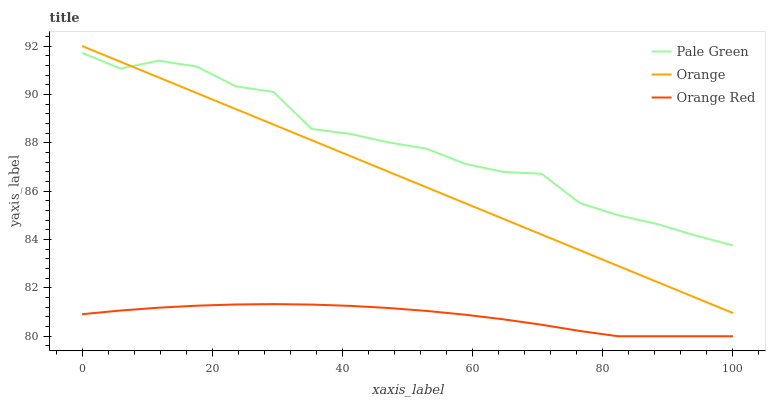Does Orange Red have the minimum area under the curve?
Answer yes or no. Yes. Does Pale Green have the maximum area under the curve?
Answer yes or no. Yes. Does Pale Green have the minimum area under the curve?
Answer yes or no. No. Does Orange Red have the maximum area under the curve?
Answer yes or no. No. Is Orange the smoothest?
Answer yes or no. Yes. Is Pale Green the roughest?
Answer yes or no. Yes. Is Orange Red the smoothest?
Answer yes or no. No. Is Orange Red the roughest?
Answer yes or no. No. Does Orange Red have the lowest value?
Answer yes or no. Yes. Does Pale Green have the lowest value?
Answer yes or no. No. Does Orange have the highest value?
Answer yes or no. Yes. Does Pale Green have the highest value?
Answer yes or no. No. Is Orange Red less than Pale Green?
Answer yes or no. Yes. Is Pale Green greater than Orange Red?
Answer yes or no. Yes. Does Pale Green intersect Orange?
Answer yes or no. Yes. Is Pale Green less than Orange?
Answer yes or no. No. Is Pale Green greater than Orange?
Answer yes or no. No. Does Orange Red intersect Pale Green?
Answer yes or no. No. 